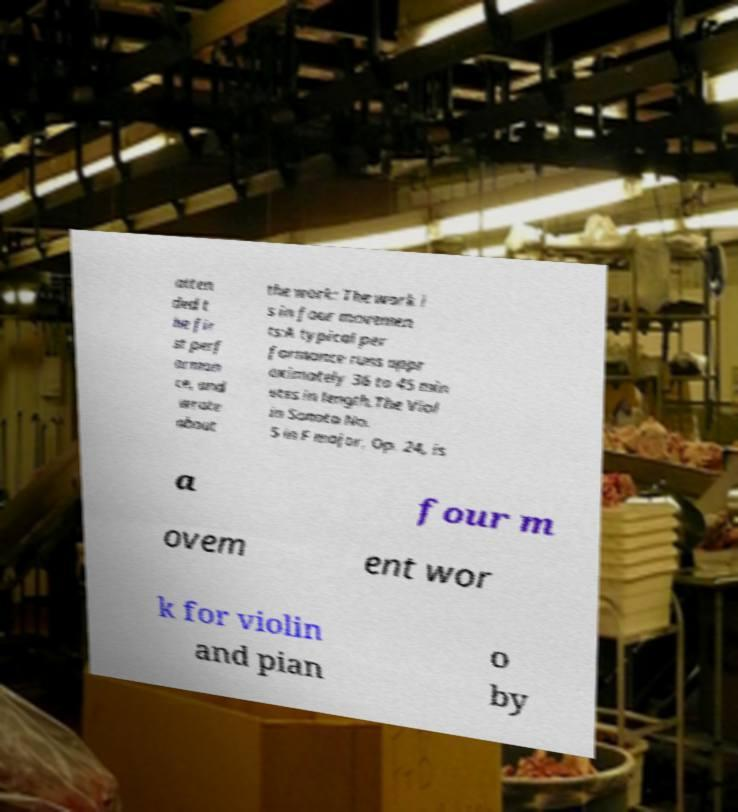I need the written content from this picture converted into text. Can you do that? atten ded t he fir st perf orman ce, and wrote about the work: The work i s in four movemen ts:A typical per formance runs appr oximately 36 to 45 min utes in length.The Viol in Sonata No. 5 in F major, Op. 24, is a four m ovem ent wor k for violin and pian o by 